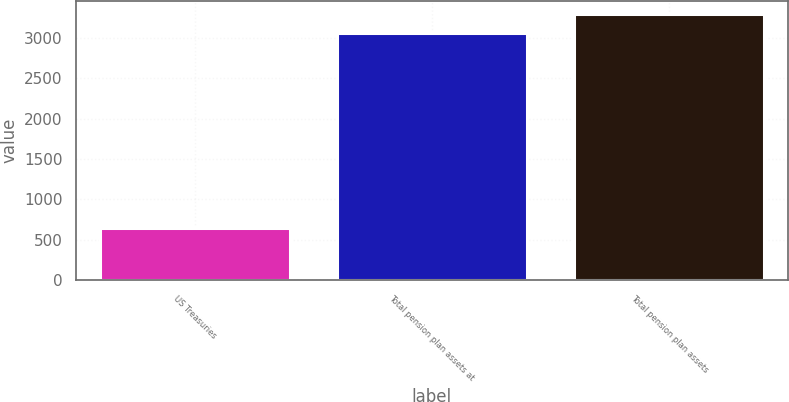Convert chart. <chart><loc_0><loc_0><loc_500><loc_500><bar_chart><fcel>US Treasuries<fcel>Total pension plan assets at<fcel>Total pension plan assets<nl><fcel>649<fcel>3054<fcel>3294.5<nl></chart> 